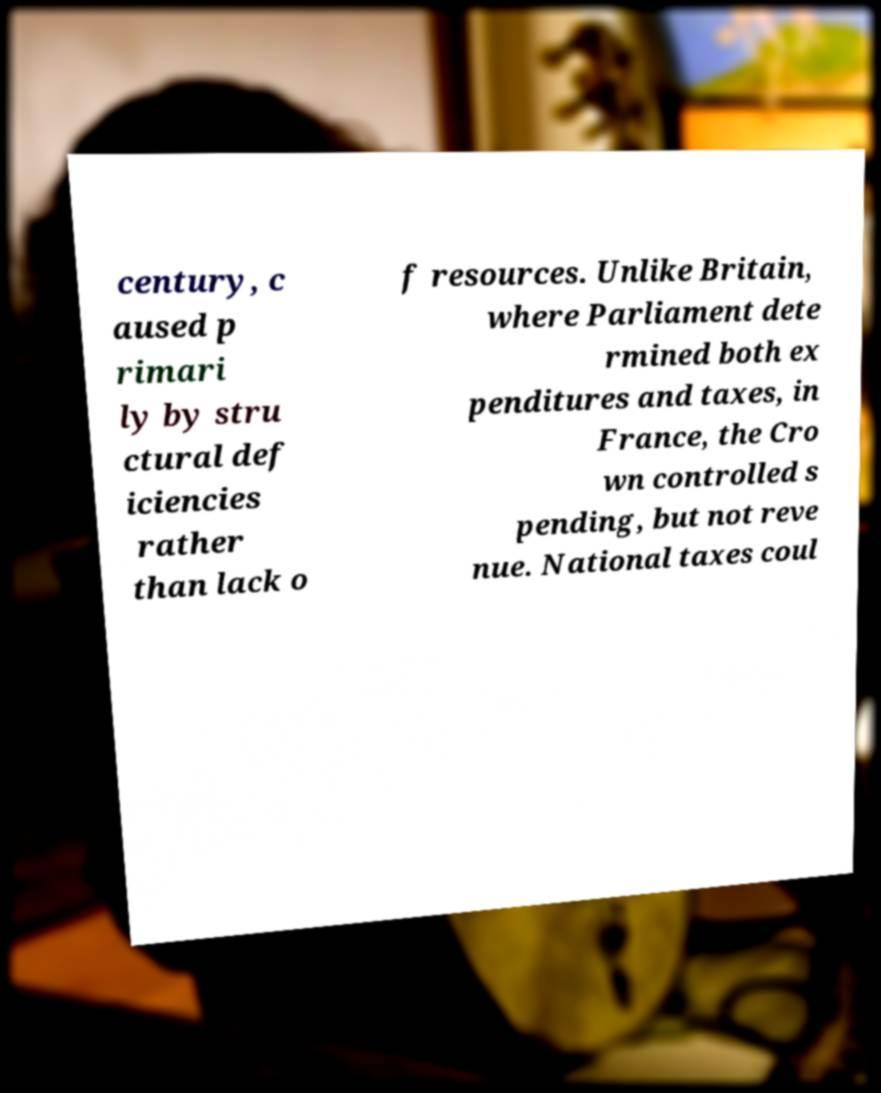Can you accurately transcribe the text from the provided image for me? century, c aused p rimari ly by stru ctural def iciencies rather than lack o f resources. Unlike Britain, where Parliament dete rmined both ex penditures and taxes, in France, the Cro wn controlled s pending, but not reve nue. National taxes coul 